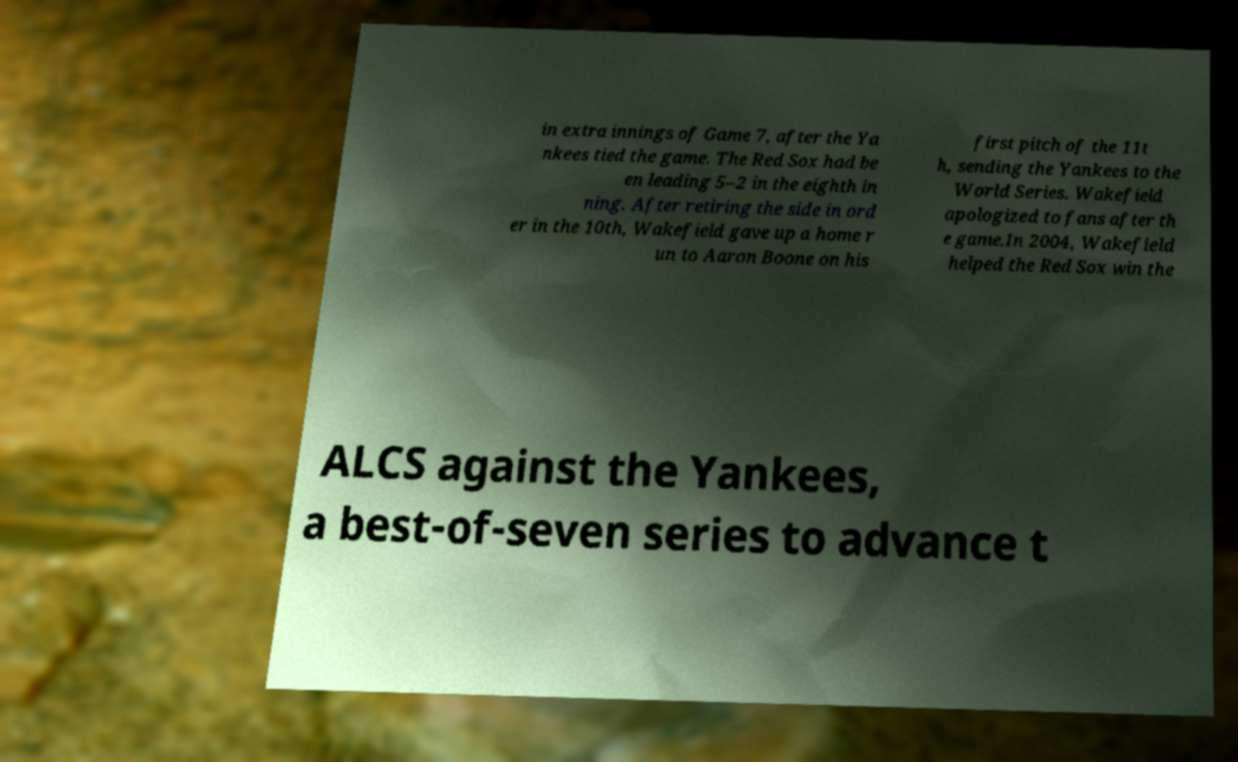Can you read and provide the text displayed in the image?This photo seems to have some interesting text. Can you extract and type it out for me? in extra innings of Game 7, after the Ya nkees tied the game. The Red Sox had be en leading 5–2 in the eighth in ning. After retiring the side in ord er in the 10th, Wakefield gave up a home r un to Aaron Boone on his first pitch of the 11t h, sending the Yankees to the World Series. Wakefield apologized to fans after th e game.In 2004, Wakefield helped the Red Sox win the ALCS against the Yankees, a best-of-seven series to advance t 